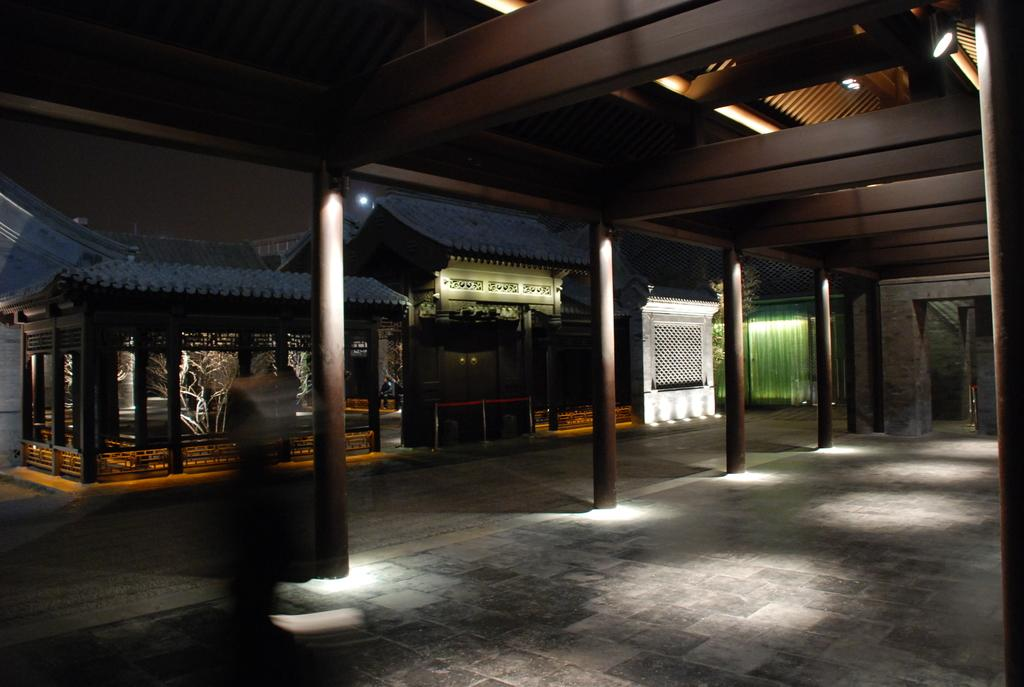What type of space is depicted in the image? The image shows an interior view of a hall. What architectural features can be seen in the hall? There are wooden pillars visible in the image. What type of structure is present above the hall? A roof shed is present in the image. What material is used for the ceiling in the hall? The ceiling in the image is made of wooden trunks. How many beginner dancers are practicing on the wooden floor in the image? There is no information about dancers or their skill level in the image, so it cannot be determined. 